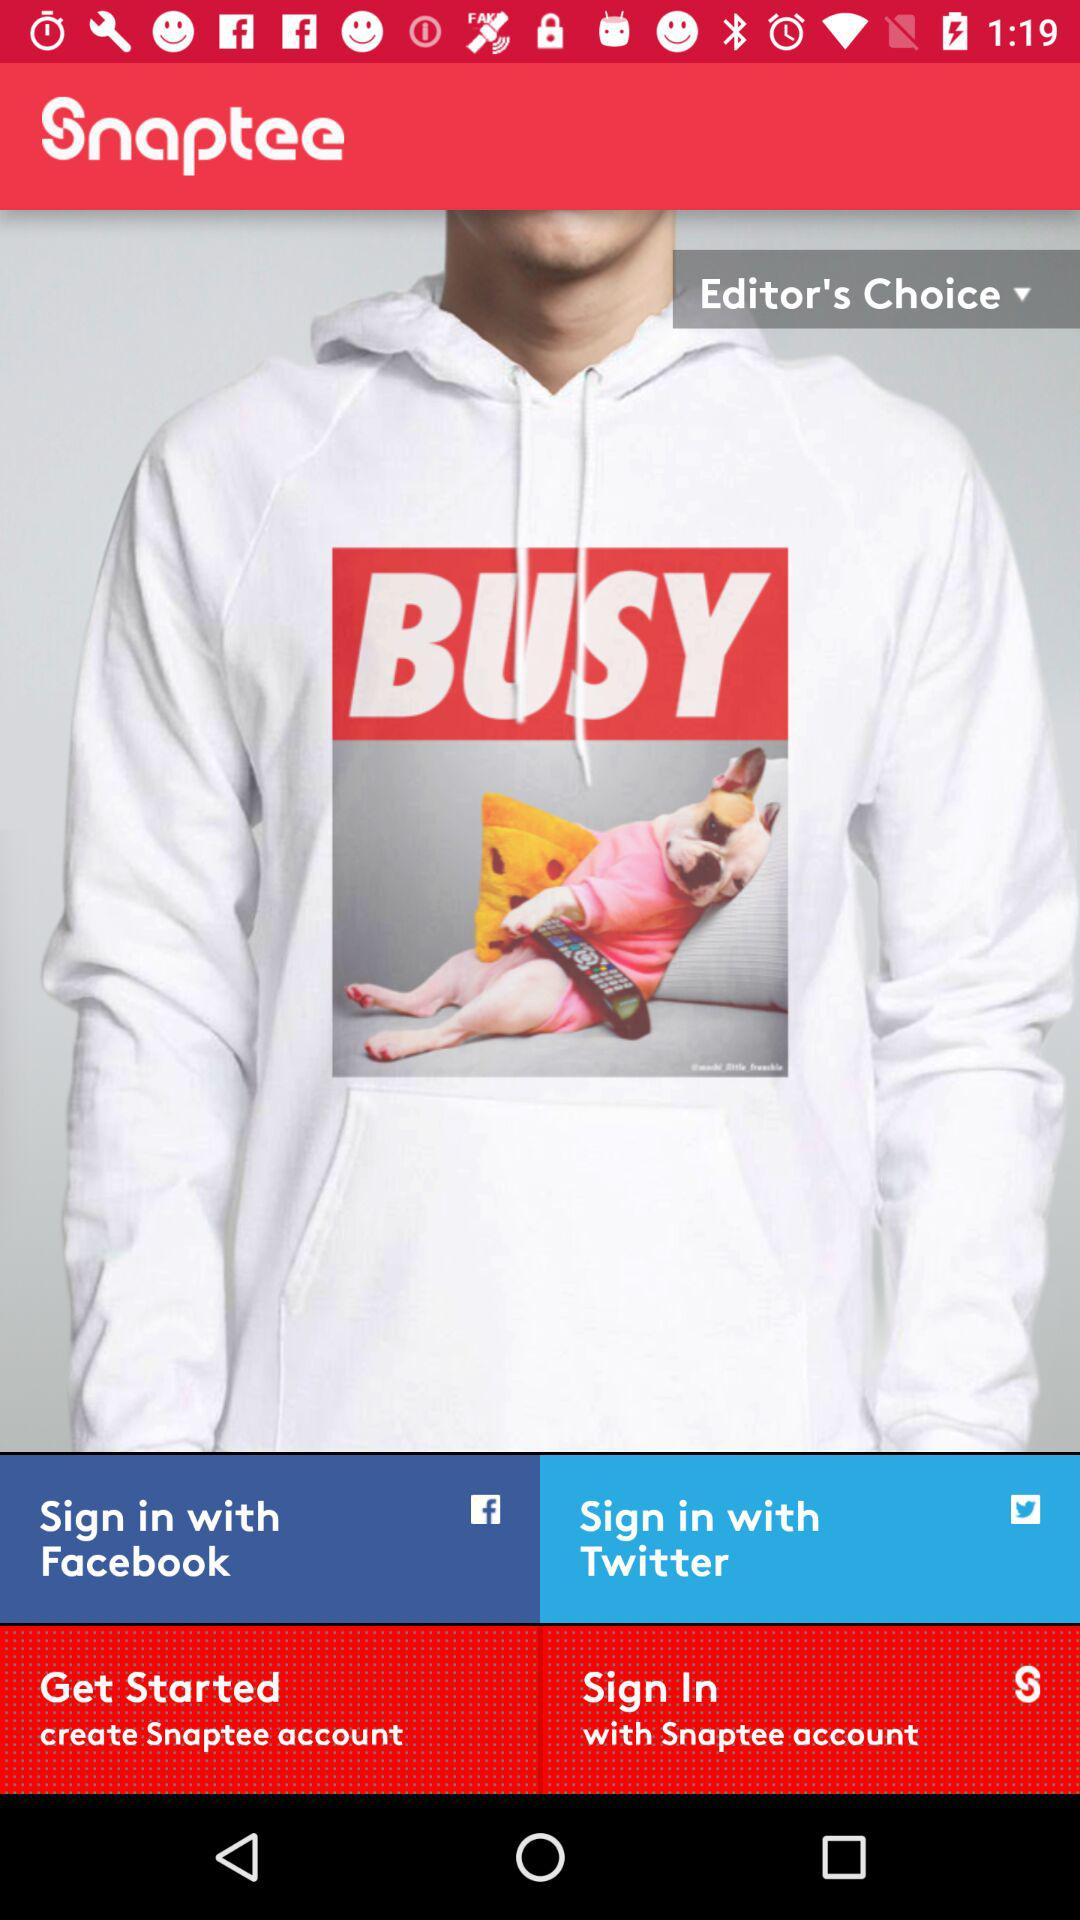What are the options through which we can sign in? You can sign in with "Sign in with Facebook", "Sign in with Twitter",and "with Snaptee account". 